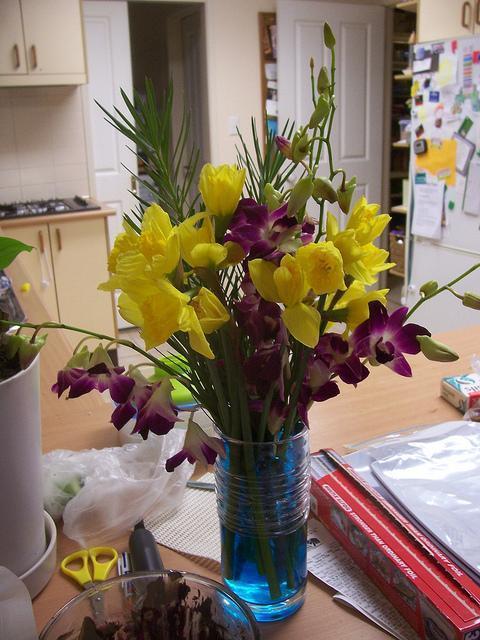How many potted plants are visible?
Give a very brief answer. 2. 